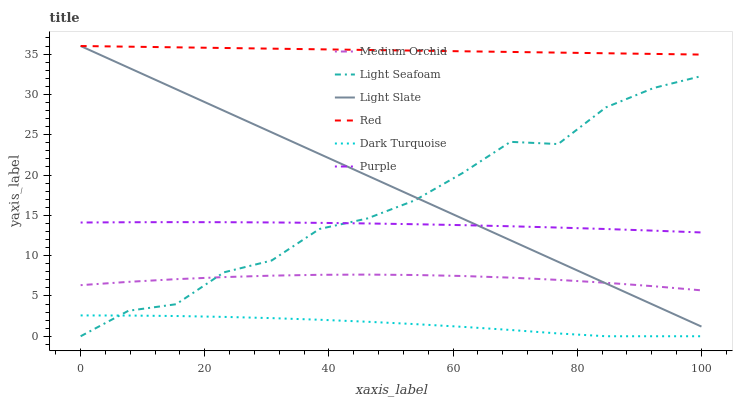Does Dark Turquoise have the minimum area under the curve?
Answer yes or no. Yes. Does Red have the maximum area under the curve?
Answer yes or no. Yes. Does Medium Orchid have the minimum area under the curve?
Answer yes or no. No. Does Medium Orchid have the maximum area under the curve?
Answer yes or no. No. Is Light Slate the smoothest?
Answer yes or no. Yes. Is Light Seafoam the roughest?
Answer yes or no. Yes. Is Dark Turquoise the smoothest?
Answer yes or no. No. Is Dark Turquoise the roughest?
Answer yes or no. No. Does Dark Turquoise have the lowest value?
Answer yes or no. Yes. Does Medium Orchid have the lowest value?
Answer yes or no. No. Does Red have the highest value?
Answer yes or no. Yes. Does Medium Orchid have the highest value?
Answer yes or no. No. Is Dark Turquoise less than Medium Orchid?
Answer yes or no. Yes. Is Red greater than Dark Turquoise?
Answer yes or no. Yes. Does Light Slate intersect Medium Orchid?
Answer yes or no. Yes. Is Light Slate less than Medium Orchid?
Answer yes or no. No. Is Light Slate greater than Medium Orchid?
Answer yes or no. No. Does Dark Turquoise intersect Medium Orchid?
Answer yes or no. No. 